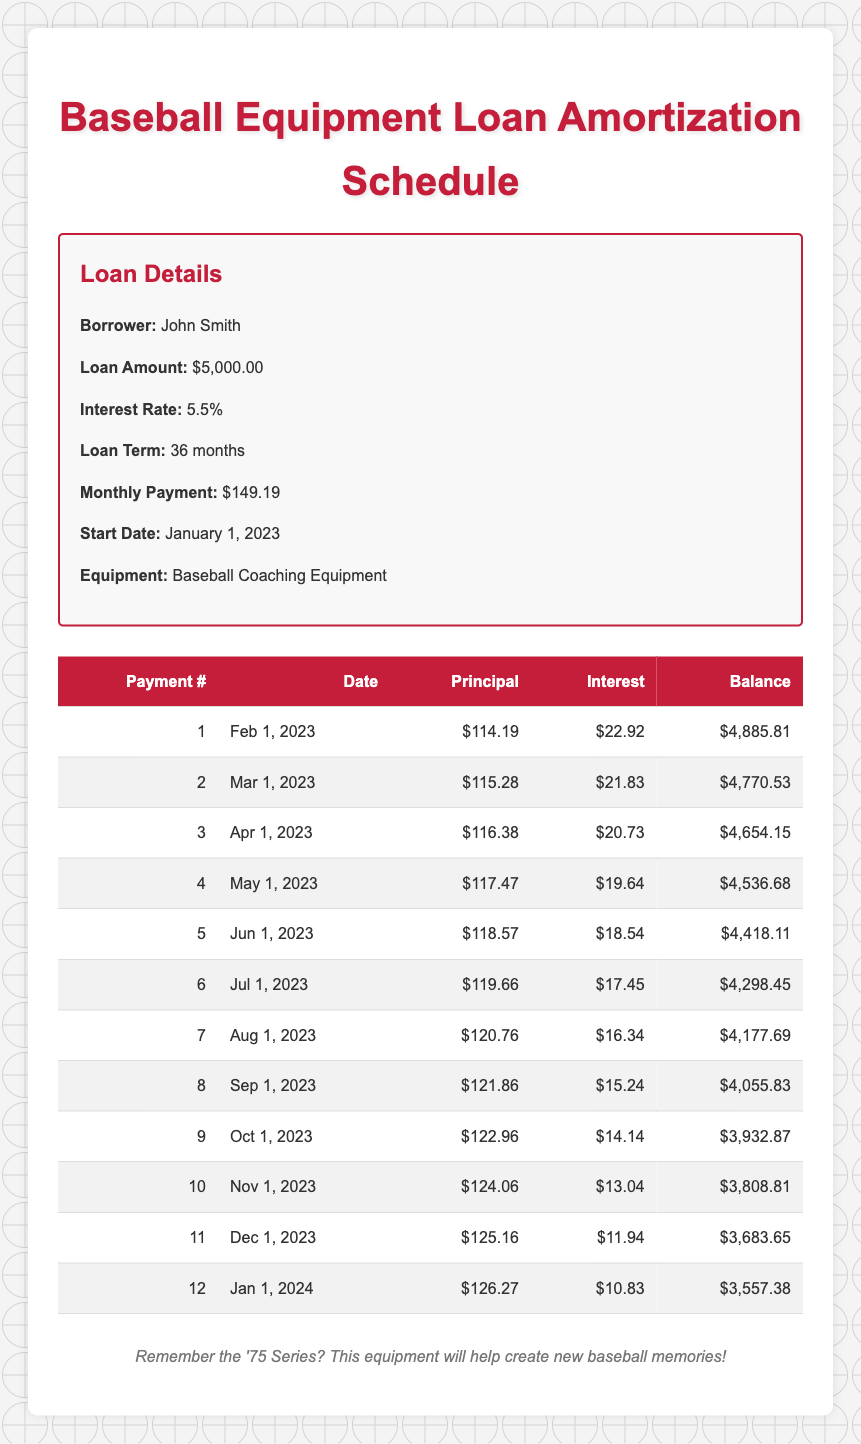What is the total amount of interest paid in the first 12 months? To find the total interest, add the interest payments for all 12 months: 22.92 + 21.83 + 20.73 + 19.64 + 18.54 + 17.45 + 16.34 + 15.24 + 14.14 + 13.04 + 11.94 + 10.83 =  220.15
Answer: 220.15 How much is the principal payment for the 6th payment? The principal payment for the 6th payment is clearly stated in the table as $119.66.
Answer: 119.66 What is the remaining balance after the 10th payment? The remaining balance after the 10th payment, displayed in the table, is $3,808.81.
Answer: 3,808.81 Is the interest payment for the 11th payment greater than the interest payment for the 9th payment? The interest payment for the 11th payment is $11.94, and for the 9th payment, it is $14.14. Since 11.94 is less than 14.14, the statement is false.
Answer: No What is the average principal payment for the first 12 months? To calculate the average, sum the principal payments for all 12 months: (114.19 + 115.28 + 116.38 + 117.47 + 118.57 + 119.66 + 120.76 + 121.86 + 122.96 + 124.06 + 125.16 + 126.27) = 1,440.27. Then divide by 12 to get the average: 1,440.27 / 12 = 120.02
Answer: 120.02 What payment number corresponds to the payment date of April 1, 2023? The payment date of April 1, 2023, corresponds to the 3rd payment as shown in the payment number column in the table.
Answer: 3 What was the biggest principal payment among the first 12 payments? Looking through the principal payments in the table, the biggest principal payment is the 12th payment at $126.27.
Answer: 126.27 Is the remaining balance after the 12th payment less than $3,500? The remaining balance after the 12th payment is $3,557.38, which is greater than $3,500; therefore, this statement is false.
Answer: No What was the total principal paid off by the end of the 12th payment? To calculate this, sum the principal payments from the first 12 payments: 114.19 + 115.28 + 116.38 + 117.47 + 118.57 + 119.66 + 120.76 + 121.86 + 122.96 + 124.06 + 125.16 + 126.27 = 1,440.27. So, the total principal paid off is $1,440.27.
Answer: 1,440.27 